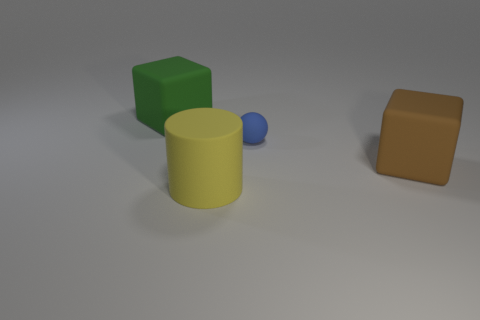What number of large things are either blue balls or green cubes? Among the objects present, there is one large blue ball. While there is also a green cube, it is not large, and hence the count of large blue balls or green cubes is one. 